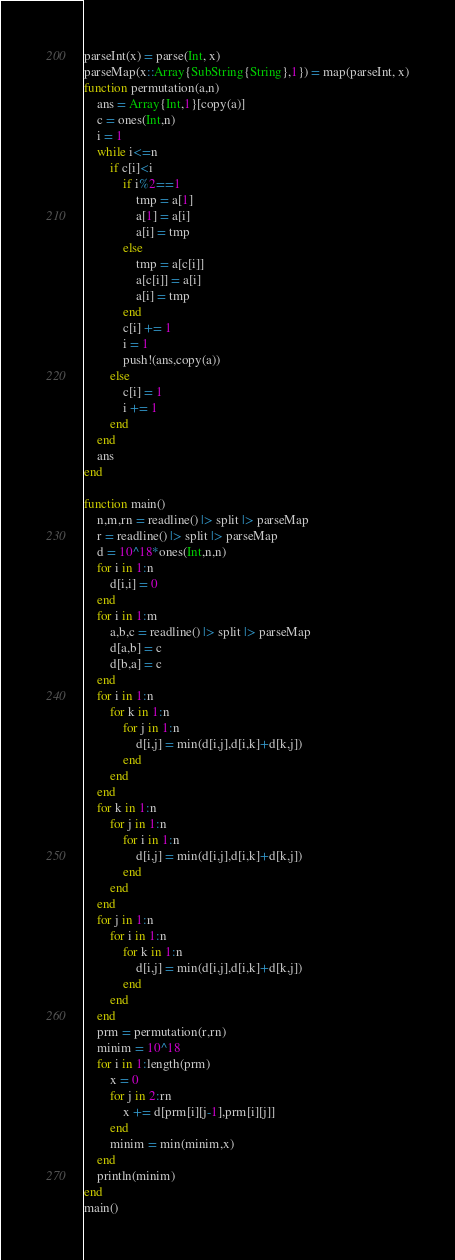Convert code to text. <code><loc_0><loc_0><loc_500><loc_500><_Julia_>parseInt(x) = parse(Int, x)
parseMap(x::Array{SubString{String},1}) = map(parseInt, x)
function permutation(a,n)
	ans = Array{Int,1}[copy(a)]
	c = ones(Int,n)
	i = 1
	while i<=n
		if c[i]<i
			if i%2==1
				tmp = a[1]
				a[1] = a[i]
				a[i] = tmp
			else
				tmp = a[c[i]]
				a[c[i]] = a[i]
				a[i] = tmp
			end
			c[i] += 1
			i = 1
			push!(ans,copy(a))
		else
			c[i] = 1
			i += 1
		end
	end
	ans
end

function main()
    n,m,rn = readline() |> split |> parseMap
    r = readline() |> split |> parseMap
    d = 10^18*ones(Int,n,n)
    for i in 1:n
        d[i,i] = 0
    end
    for i in 1:m
        a,b,c = readline() |> split |> parseMap
        d[a,b] = c
        d[b,a] = c
    end
    for i in 1:n
        for k in 1:n
            for j in 1:n
                d[i,j] = min(d[i,j],d[i,k]+d[k,j])
            end
        end
    end
    for k in 1:n
        for j in 1:n
            for i in 1:n
                d[i,j] = min(d[i,j],d[i,k]+d[k,j])
            end
        end
    end
    for j in 1:n
        for i in 1:n
            for k in 1:n
                d[i,j] = min(d[i,j],d[i,k]+d[k,j])
            end
        end
    end
    prm = permutation(r,rn)
    minim = 10^18
    for i in 1:length(prm)
        x = 0
        for j in 2:rn
            x += d[prm[i][j-1],prm[i][j]]
        end
        minim = min(minim,x)
    end
    println(minim)
end
main()</code> 